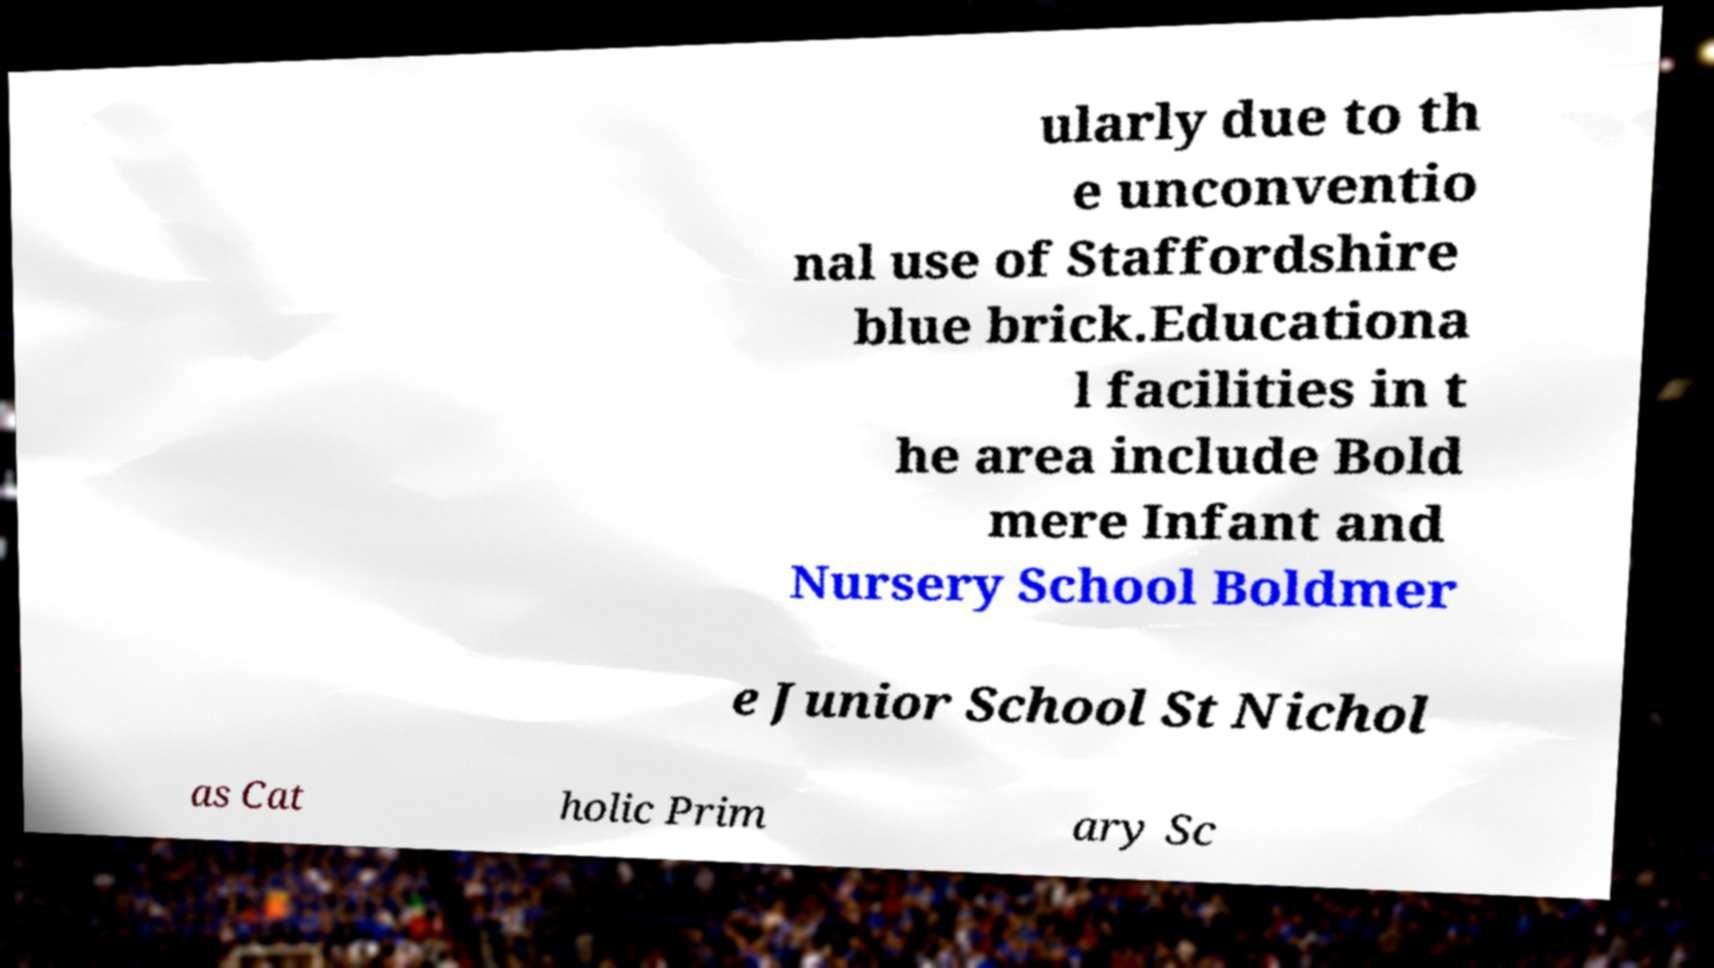I need the written content from this picture converted into text. Can you do that? ularly due to th e unconventio nal use of Staffordshire blue brick.Educationa l facilities in t he area include Bold mere Infant and Nursery School Boldmer e Junior School St Nichol as Cat holic Prim ary Sc 